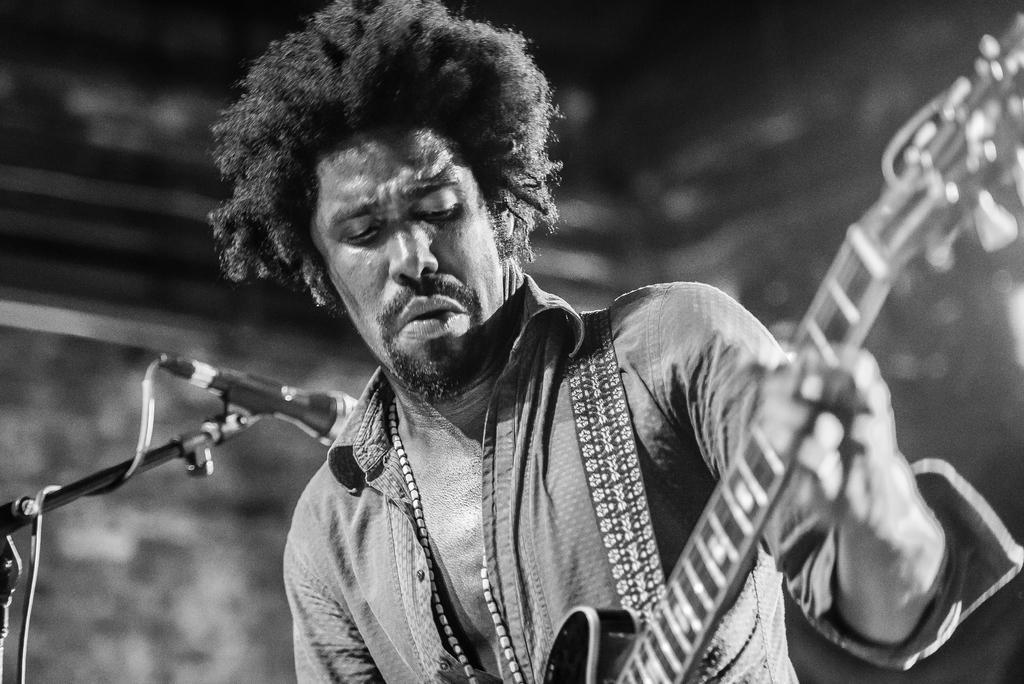How would you summarize this image in a sentence or two? A man is playing guitar. There is a mic beside him. 